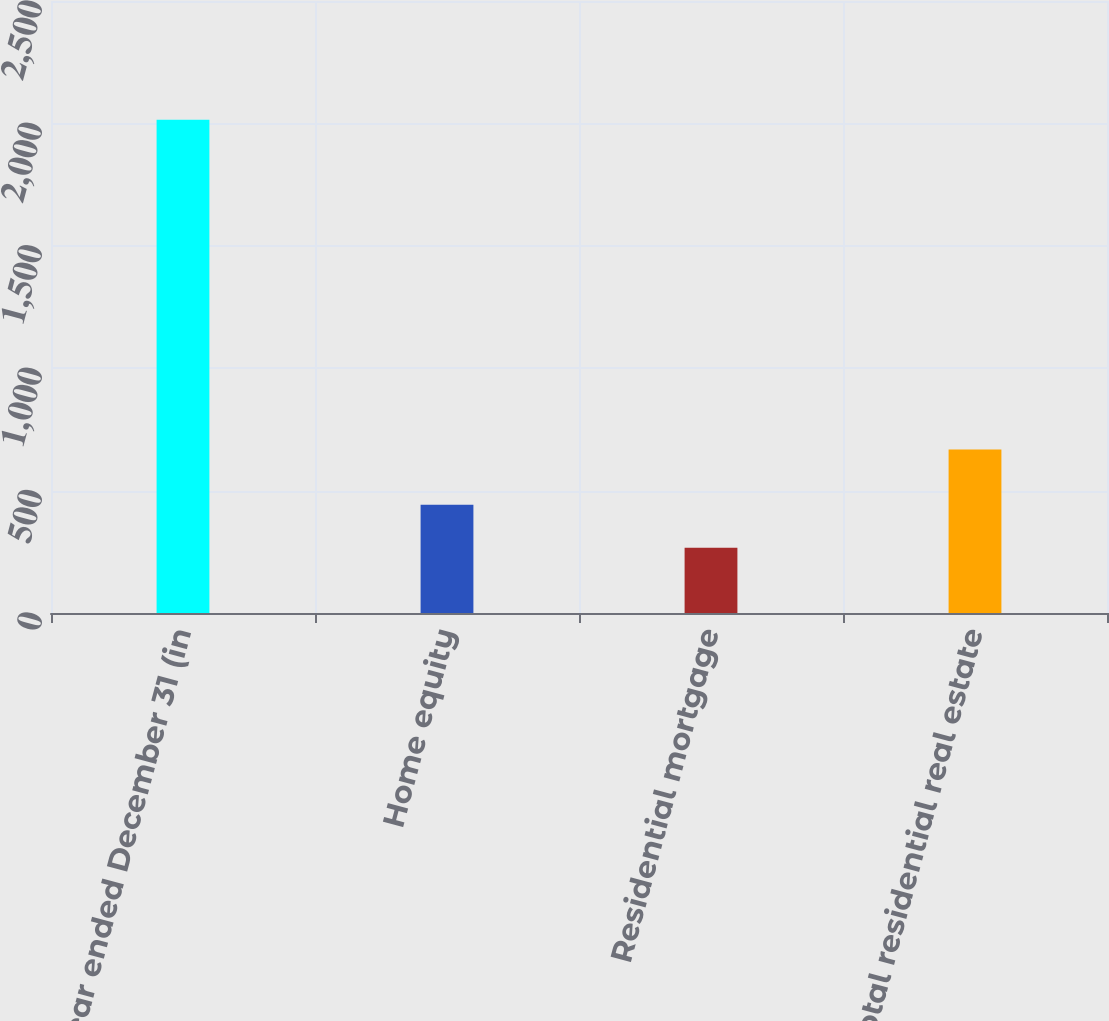Convert chart to OTSL. <chart><loc_0><loc_0><loc_500><loc_500><bar_chart><fcel>Year ended December 31 (in<fcel>Home equity<fcel>Residential mortgage<fcel>Total residential real estate<nl><fcel>2015<fcel>441.8<fcel>267<fcel>668<nl></chart> 